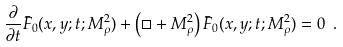Convert formula to latex. <formula><loc_0><loc_0><loc_500><loc_500>\frac { \partial } { \partial t } \bar { F } _ { 0 } ( x , y ; t ; M _ { \rho } ^ { 2 } ) + \left ( \Box + M _ { \rho } ^ { 2 } \right ) \bar { F } _ { 0 } ( x , y ; t ; M _ { \rho } ^ { 2 } ) = 0 \ .</formula> 